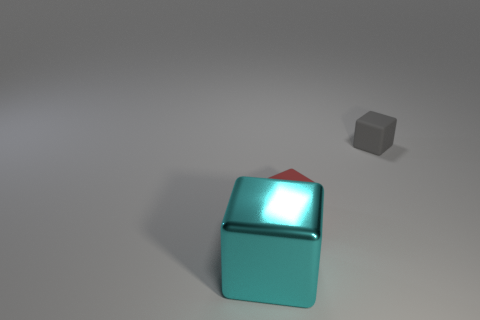Add 2 tiny gray things. How many objects exist? 5 Subtract all red matte objects. Subtract all tiny red rubber objects. How many objects are left? 1 Add 2 tiny blocks. How many tiny blocks are left? 4 Add 3 cyan metal objects. How many cyan metal objects exist? 4 Subtract 1 gray blocks. How many objects are left? 2 